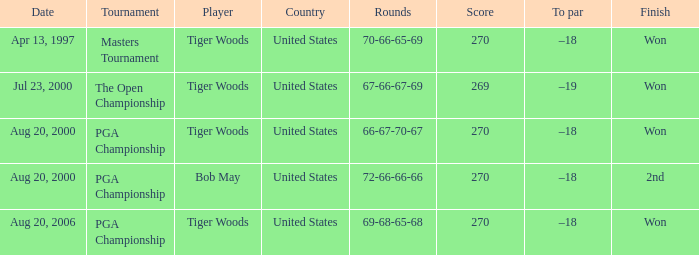What days were the rounds of 66-67-70-67 recorded? Aug 20, 2000. 